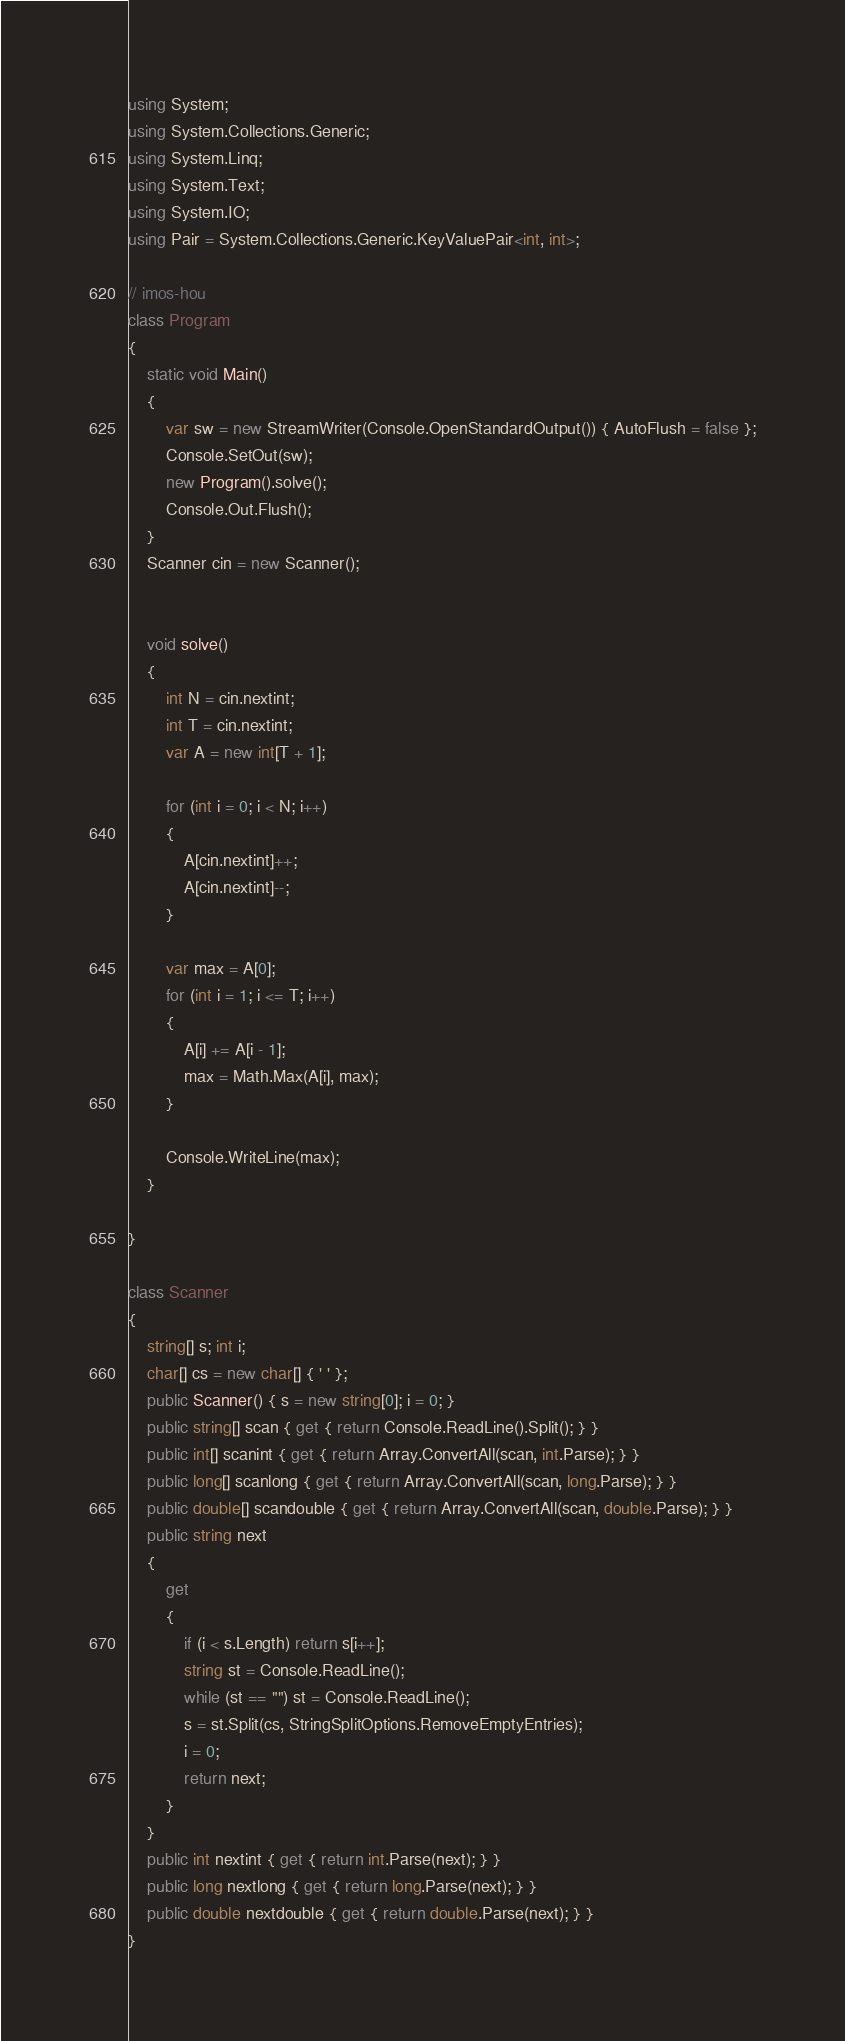<code> <loc_0><loc_0><loc_500><loc_500><_C#_>using System;
using System.Collections.Generic;
using System.Linq;
using System.Text;
using System.IO;
using Pair = System.Collections.Generic.KeyValuePair<int, int>;

// imos-hou
class Program
{
    static void Main()
    {
        var sw = new StreamWriter(Console.OpenStandardOutput()) { AutoFlush = false };
        Console.SetOut(sw);
        new Program().solve();
        Console.Out.Flush();
    }
    Scanner cin = new Scanner();


    void solve()
    {
        int N = cin.nextint;
        int T = cin.nextint;
        var A = new int[T + 1];

        for (int i = 0; i < N; i++)
        {
            A[cin.nextint]++;
            A[cin.nextint]--;
        }

        var max = A[0];
        for (int i = 1; i <= T; i++)
        {
            A[i] += A[i - 1];
            max = Math.Max(A[i], max);
        }

        Console.WriteLine(max);
    }

}

class Scanner
{
    string[] s; int i;
    char[] cs = new char[] { ' ' };
    public Scanner() { s = new string[0]; i = 0; }
    public string[] scan { get { return Console.ReadLine().Split(); } }
    public int[] scanint { get { return Array.ConvertAll(scan, int.Parse); } }
    public long[] scanlong { get { return Array.ConvertAll(scan, long.Parse); } }
    public double[] scandouble { get { return Array.ConvertAll(scan, double.Parse); } }
    public string next
    {
        get
        {
            if (i < s.Length) return s[i++];
            string st = Console.ReadLine();
            while (st == "") st = Console.ReadLine();
            s = st.Split(cs, StringSplitOptions.RemoveEmptyEntries);
            i = 0;
            return next;
        }
    }
    public int nextint { get { return int.Parse(next); } }
    public long nextlong { get { return long.Parse(next); } }
    public double nextdouble { get { return double.Parse(next); } }
}</code> 